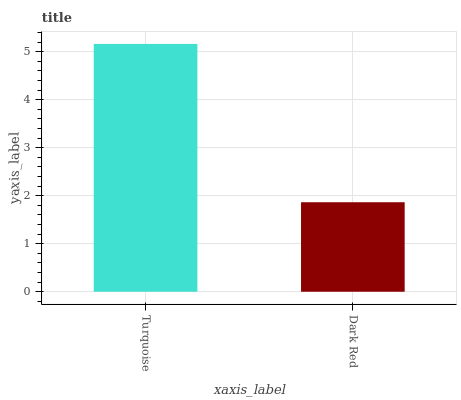Is Dark Red the minimum?
Answer yes or no. Yes. Is Turquoise the maximum?
Answer yes or no. Yes. Is Dark Red the maximum?
Answer yes or no. No. Is Turquoise greater than Dark Red?
Answer yes or no. Yes. Is Dark Red less than Turquoise?
Answer yes or no. Yes. Is Dark Red greater than Turquoise?
Answer yes or no. No. Is Turquoise less than Dark Red?
Answer yes or no. No. Is Turquoise the high median?
Answer yes or no. Yes. Is Dark Red the low median?
Answer yes or no. Yes. Is Dark Red the high median?
Answer yes or no. No. Is Turquoise the low median?
Answer yes or no. No. 